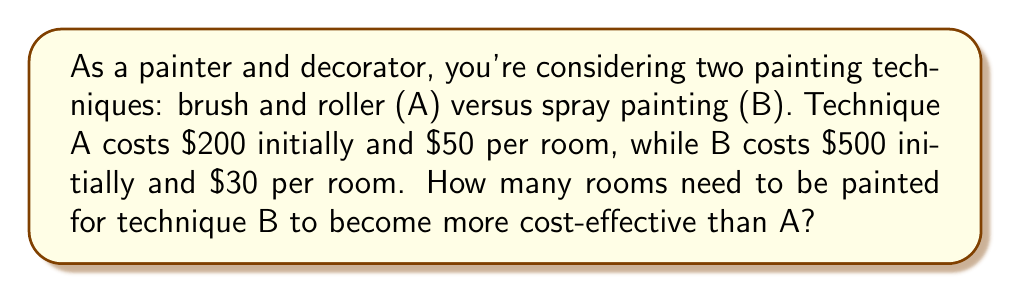What is the answer to this math problem? Let's approach this step-by-step:

1) Let $x$ be the number of rooms painted.

2) Cost for technique A:
   $$C_A = 200 + 50x$$

3) Cost for technique B:
   $$C_B = 500 + 30x$$

4) For B to be more cost-effective, its total cost should be less than A:
   $$C_B < C_A$$
   $$500 + 30x < 200 + 50x$$

5) Solving the inequality:
   $$300 < 20x$$
   $$15 < x$$

6) Since we're dealing with whole rooms, we need to round up to the next integer.

Therefore, technique B becomes more cost-effective when painting 16 or more rooms.

This problem is an inverse problem because we're determining the input (number of rooms) that results in a specific output (cost-effectiveness comparison), rather than calculating the output from a given input.
Answer: 16 rooms 